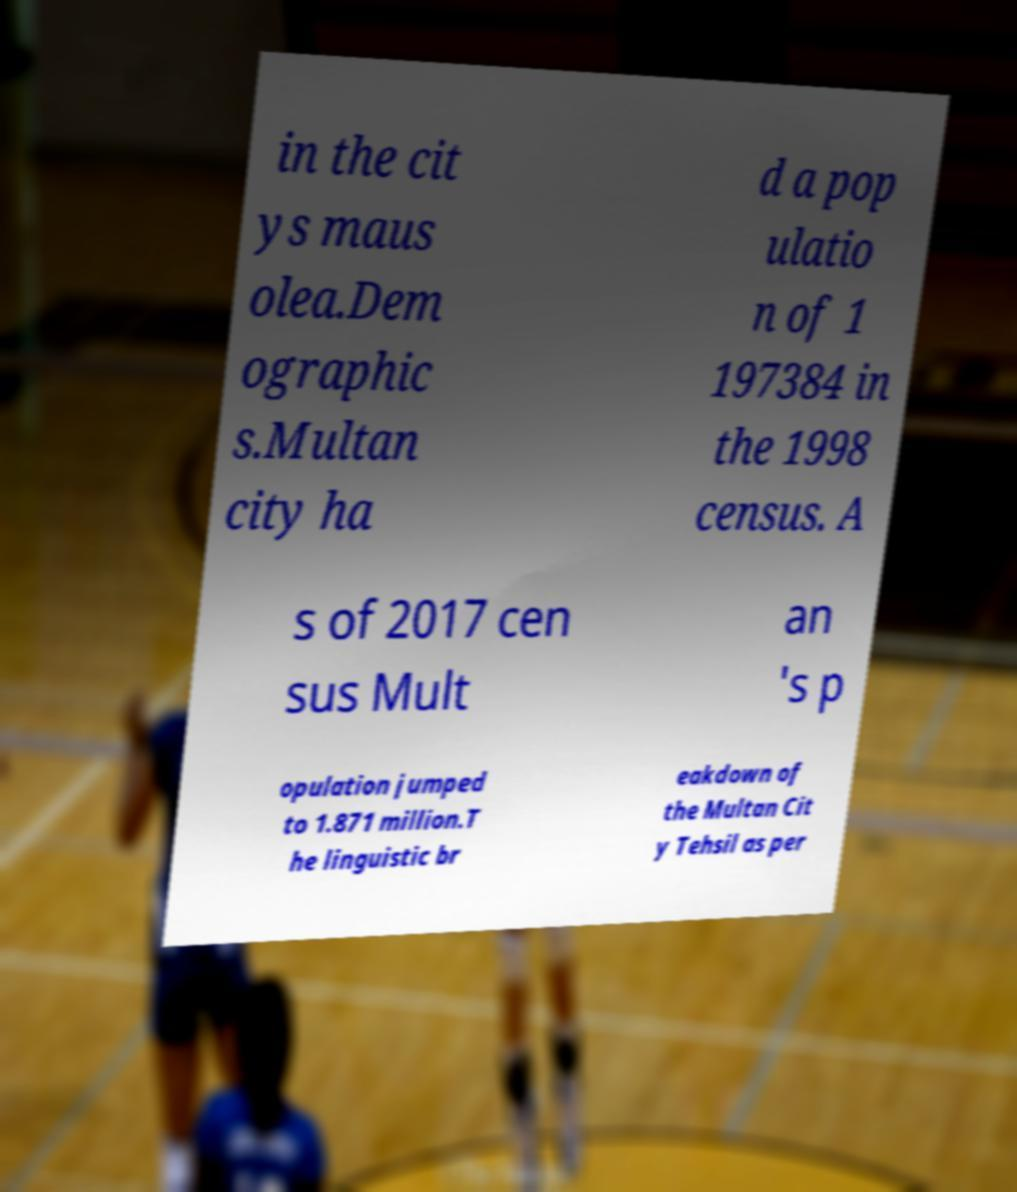Can you read and provide the text displayed in the image?This photo seems to have some interesting text. Can you extract and type it out for me? in the cit ys maus olea.Dem ographic s.Multan city ha d a pop ulatio n of 1 197384 in the 1998 census. A s of 2017 cen sus Mult an 's p opulation jumped to 1.871 million.T he linguistic br eakdown of the Multan Cit y Tehsil as per 